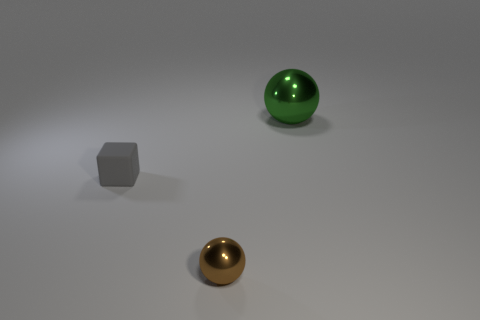Add 1 red metal cubes. How many objects exist? 4 Subtract all blocks. How many objects are left? 2 Subtract 2 spheres. How many spheres are left? 0 Subtract all red cubes. Subtract all brown balls. How many cubes are left? 1 Subtract all yellow cubes. How many cyan spheres are left? 0 Subtract all small brown rubber things. Subtract all matte blocks. How many objects are left? 2 Add 2 tiny metallic spheres. How many tiny metallic spheres are left? 3 Add 3 large red things. How many large red things exist? 3 Subtract 0 green cylinders. How many objects are left? 3 